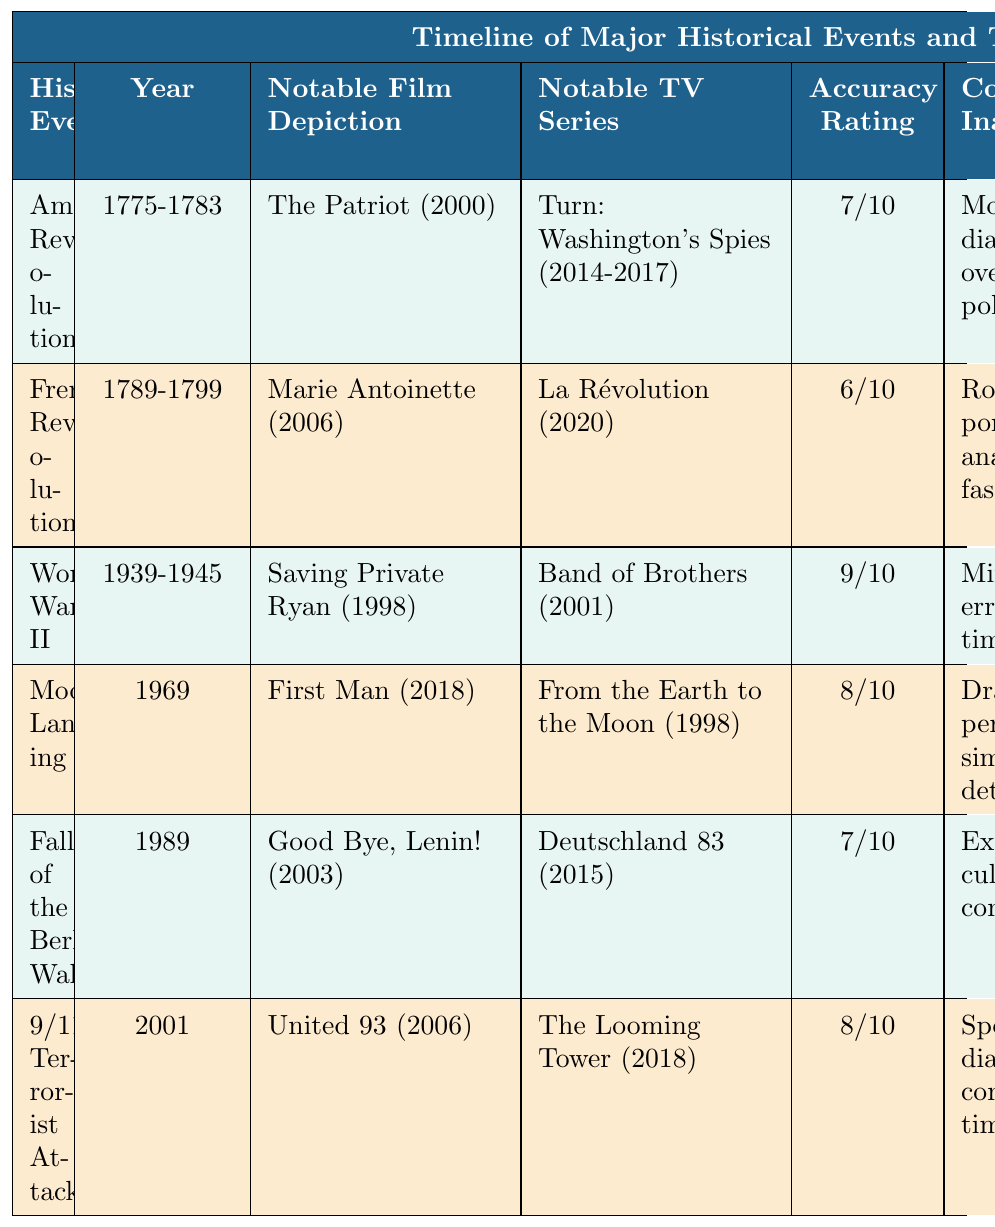What is the historical accuracy rating of the French Revolution's media depictions? The French Revolution has a historical accuracy rating of 6/10 as listed in the table.
Answer: 6/10 Which notable film depicts the Moon Landing? The film "First Man (2018)" depicts the Moon Landing according to the table.
Answer: First Man (2018) What are the common inaccuracies associated with the depiction of World War II? The table lists the common inaccuracies for World War II as minor tactical errors and a compressed timeline.
Answer: Minor tactical errors, compressed timeline Who is the recommended historical consultant for information on the American Revolution? Dr. Gordon S. Wood is the recommended historical consultant for the American Revolution based on the table information.
Answer: Dr. Gordon S. Wood Which historical event has the highest accuracy rating? The table indicates that World War II has the highest accuracy rating at 9/10.
Answer: World War II Is "Good Bye, Lenin!" a notable depiction for the Moon Landing? No, "Good Bye, Lenin!" is a notable depiction for the Fall of the Berlin Wall, not the Moon Landing.
Answer: No What are the recommended historical consultants for events depicting the 9/11 Terrorist Attacks? The table indicates that Dr. Lawrence Wright is the recommended consultant for the 9/11 Terrorist Attacks.
Answer: Dr. Lawrence Wright What is the average accuracy rating for all the historical events listed in the table? The accuracy ratings are 7, 6, 9, 8, 7, and 8. Summing them gives 45. Dividing by 6 (the number of events) gives an average accuracy rating of 7.5.
Answer: 7.5 Which notable TV series corresponds with the Fall of the Berlin Wall? The notable TV series for the Fall of the Berlin Wall is "Deutschland 83 (2015)" according to the table.
Answer: Deutschland 83 (2015) Do the notable TV series for World War II and the American Revolution share the same accuracy rating? No, the American Revolution has a rating of 7/10 while World War II has a rating of 9/10, which means they do not share the same rating.
Answer: No What common inaccuracies are associated with the depiction of the French Revolution? The table lists the common inaccuracies for the French Revolution as romanticized portrayal and anachronistic fashion.
Answer: Romanticized portrayal, anachronistic fashion 